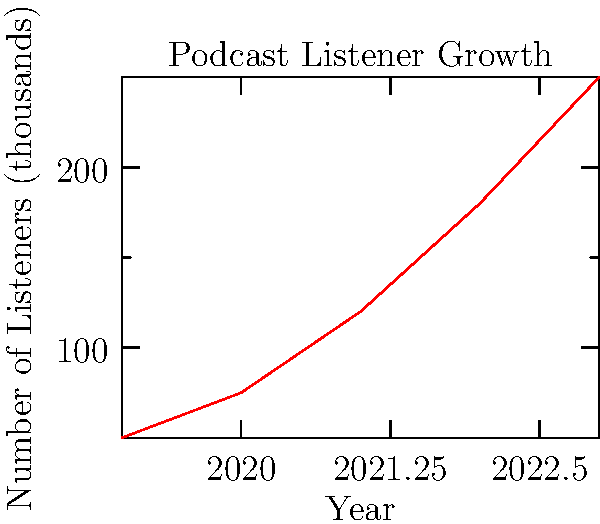Based on the line graph showing podcast listener growth from 2019 to 2023, what strategy would you recommend to maintain this upward trend and potentially accelerate growth in the coming years? To answer this question, let's analyze the graph and consider strategies that align with the growth trend:

1. Observe the trend: The graph shows a consistent upward trend in podcast listeners from 2019 to 2023.

2. Calculate growth rate: The growth is not linear but accelerating. From 2019 to 2020, growth was 50% (25,000 new listeners). From 2022 to 2023, growth was about 39% but represented 70,000 new listeners.

3. Consider factors behind growth: The rapid increase could be due to improved content quality, increased marketing efforts, or growing popularity of podcasts in general.

4. Identify potential strategies:
   a) Content diversification: Expand into new topics or formats to attract a wider audience.
   b) Collaborations: Partner with other podcasters or influencers to cross-promote.
   c) Multi-platform presence: Ensure the podcast is available on all major platforms and promote on social media.
   d) Interactive elements: Incorporate listener feedback, Q&A sessions, or live episodes to increase engagement.
   e) Targeted advertising: Use data analytics to reach potential listeners more effectively.

5. Align with executive perspective: As a forward-thinking executive, focus on scalable, data-driven strategies that can sustain and accelerate growth.

Given these considerations, a recommended strategy would be to implement a combination of content diversification and data-driven targeted advertising. This approach leverages the existing growth trend while expanding the potential audience base and using analytics to optimize reach and engagement.
Answer: Implement content diversification and data-driven targeted advertising 